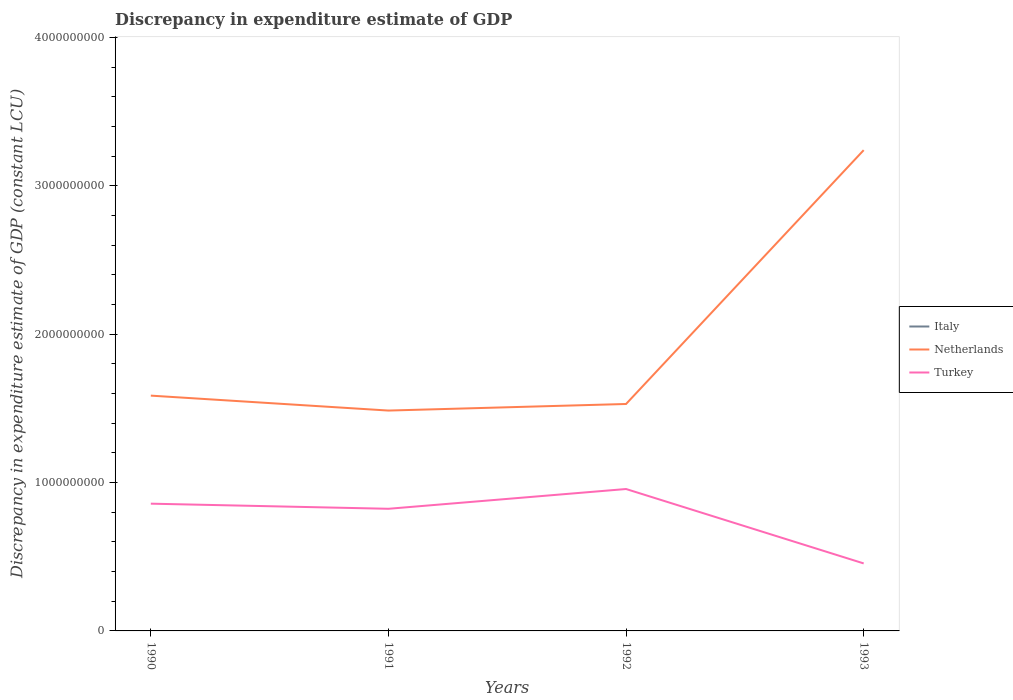How many different coloured lines are there?
Your response must be concise. 2. Across all years, what is the maximum discrepancy in expenditure estimate of GDP in Italy?
Offer a terse response. 0. What is the total discrepancy in expenditure estimate of GDP in Turkey in the graph?
Offer a terse response. 5.02e+08. What is the difference between the highest and the second highest discrepancy in expenditure estimate of GDP in Netherlands?
Provide a short and direct response. 1.76e+09. What is the difference between the highest and the lowest discrepancy in expenditure estimate of GDP in Italy?
Provide a short and direct response. 0. Is the discrepancy in expenditure estimate of GDP in Italy strictly greater than the discrepancy in expenditure estimate of GDP in Turkey over the years?
Offer a terse response. Yes. How many lines are there?
Provide a succinct answer. 2. How many years are there in the graph?
Your response must be concise. 4. What is the difference between two consecutive major ticks on the Y-axis?
Give a very brief answer. 1.00e+09. Does the graph contain any zero values?
Offer a terse response. Yes. Where does the legend appear in the graph?
Provide a short and direct response. Center right. How many legend labels are there?
Offer a very short reply. 3. What is the title of the graph?
Keep it short and to the point. Discrepancy in expenditure estimate of GDP. Does "Virgin Islands" appear as one of the legend labels in the graph?
Provide a succinct answer. No. What is the label or title of the Y-axis?
Keep it short and to the point. Discrepancy in expenditure estimate of GDP (constant LCU). What is the Discrepancy in expenditure estimate of GDP (constant LCU) in Netherlands in 1990?
Offer a terse response. 1.59e+09. What is the Discrepancy in expenditure estimate of GDP (constant LCU) of Turkey in 1990?
Give a very brief answer. 8.58e+08. What is the Discrepancy in expenditure estimate of GDP (constant LCU) of Italy in 1991?
Offer a terse response. 0. What is the Discrepancy in expenditure estimate of GDP (constant LCU) in Netherlands in 1991?
Keep it short and to the point. 1.49e+09. What is the Discrepancy in expenditure estimate of GDP (constant LCU) in Turkey in 1991?
Keep it short and to the point. 8.23e+08. What is the Discrepancy in expenditure estimate of GDP (constant LCU) of Netherlands in 1992?
Keep it short and to the point. 1.53e+09. What is the Discrepancy in expenditure estimate of GDP (constant LCU) in Turkey in 1992?
Ensure brevity in your answer.  9.57e+08. What is the Discrepancy in expenditure estimate of GDP (constant LCU) of Netherlands in 1993?
Give a very brief answer. 3.24e+09. What is the Discrepancy in expenditure estimate of GDP (constant LCU) of Turkey in 1993?
Your response must be concise. 4.55e+08. Across all years, what is the maximum Discrepancy in expenditure estimate of GDP (constant LCU) of Netherlands?
Offer a terse response. 3.24e+09. Across all years, what is the maximum Discrepancy in expenditure estimate of GDP (constant LCU) in Turkey?
Ensure brevity in your answer.  9.57e+08. Across all years, what is the minimum Discrepancy in expenditure estimate of GDP (constant LCU) of Netherlands?
Your answer should be compact. 1.49e+09. Across all years, what is the minimum Discrepancy in expenditure estimate of GDP (constant LCU) in Turkey?
Your response must be concise. 4.55e+08. What is the total Discrepancy in expenditure estimate of GDP (constant LCU) of Italy in the graph?
Your response must be concise. 0. What is the total Discrepancy in expenditure estimate of GDP (constant LCU) of Netherlands in the graph?
Keep it short and to the point. 7.84e+09. What is the total Discrepancy in expenditure estimate of GDP (constant LCU) of Turkey in the graph?
Keep it short and to the point. 3.09e+09. What is the difference between the Discrepancy in expenditure estimate of GDP (constant LCU) of Netherlands in 1990 and that in 1991?
Your answer should be very brief. 1.01e+08. What is the difference between the Discrepancy in expenditure estimate of GDP (constant LCU) in Turkey in 1990 and that in 1991?
Offer a very short reply. 3.45e+07. What is the difference between the Discrepancy in expenditure estimate of GDP (constant LCU) of Netherlands in 1990 and that in 1992?
Make the answer very short. 5.64e+07. What is the difference between the Discrepancy in expenditure estimate of GDP (constant LCU) in Turkey in 1990 and that in 1992?
Make the answer very short. -9.88e+07. What is the difference between the Discrepancy in expenditure estimate of GDP (constant LCU) in Netherlands in 1990 and that in 1993?
Provide a short and direct response. -1.66e+09. What is the difference between the Discrepancy in expenditure estimate of GDP (constant LCU) in Turkey in 1990 and that in 1993?
Your answer should be very brief. 4.03e+08. What is the difference between the Discrepancy in expenditure estimate of GDP (constant LCU) of Netherlands in 1991 and that in 1992?
Your response must be concise. -4.44e+07. What is the difference between the Discrepancy in expenditure estimate of GDP (constant LCU) in Turkey in 1991 and that in 1992?
Your answer should be very brief. -1.33e+08. What is the difference between the Discrepancy in expenditure estimate of GDP (constant LCU) in Netherlands in 1991 and that in 1993?
Provide a short and direct response. -1.76e+09. What is the difference between the Discrepancy in expenditure estimate of GDP (constant LCU) in Turkey in 1991 and that in 1993?
Offer a very short reply. 3.68e+08. What is the difference between the Discrepancy in expenditure estimate of GDP (constant LCU) in Netherlands in 1992 and that in 1993?
Offer a very short reply. -1.71e+09. What is the difference between the Discrepancy in expenditure estimate of GDP (constant LCU) of Turkey in 1992 and that in 1993?
Ensure brevity in your answer.  5.02e+08. What is the difference between the Discrepancy in expenditure estimate of GDP (constant LCU) in Netherlands in 1990 and the Discrepancy in expenditure estimate of GDP (constant LCU) in Turkey in 1991?
Your response must be concise. 7.63e+08. What is the difference between the Discrepancy in expenditure estimate of GDP (constant LCU) of Netherlands in 1990 and the Discrepancy in expenditure estimate of GDP (constant LCU) of Turkey in 1992?
Your response must be concise. 6.30e+08. What is the difference between the Discrepancy in expenditure estimate of GDP (constant LCU) in Netherlands in 1990 and the Discrepancy in expenditure estimate of GDP (constant LCU) in Turkey in 1993?
Provide a succinct answer. 1.13e+09. What is the difference between the Discrepancy in expenditure estimate of GDP (constant LCU) in Netherlands in 1991 and the Discrepancy in expenditure estimate of GDP (constant LCU) in Turkey in 1992?
Provide a succinct answer. 5.29e+08. What is the difference between the Discrepancy in expenditure estimate of GDP (constant LCU) in Netherlands in 1991 and the Discrepancy in expenditure estimate of GDP (constant LCU) in Turkey in 1993?
Make the answer very short. 1.03e+09. What is the difference between the Discrepancy in expenditure estimate of GDP (constant LCU) of Netherlands in 1992 and the Discrepancy in expenditure estimate of GDP (constant LCU) of Turkey in 1993?
Provide a short and direct response. 1.08e+09. What is the average Discrepancy in expenditure estimate of GDP (constant LCU) of Italy per year?
Offer a terse response. 0. What is the average Discrepancy in expenditure estimate of GDP (constant LCU) of Netherlands per year?
Give a very brief answer. 1.96e+09. What is the average Discrepancy in expenditure estimate of GDP (constant LCU) of Turkey per year?
Your answer should be compact. 7.73e+08. In the year 1990, what is the difference between the Discrepancy in expenditure estimate of GDP (constant LCU) in Netherlands and Discrepancy in expenditure estimate of GDP (constant LCU) in Turkey?
Provide a short and direct response. 7.29e+08. In the year 1991, what is the difference between the Discrepancy in expenditure estimate of GDP (constant LCU) in Netherlands and Discrepancy in expenditure estimate of GDP (constant LCU) in Turkey?
Provide a short and direct response. 6.62e+08. In the year 1992, what is the difference between the Discrepancy in expenditure estimate of GDP (constant LCU) in Netherlands and Discrepancy in expenditure estimate of GDP (constant LCU) in Turkey?
Your answer should be very brief. 5.73e+08. In the year 1993, what is the difference between the Discrepancy in expenditure estimate of GDP (constant LCU) in Netherlands and Discrepancy in expenditure estimate of GDP (constant LCU) in Turkey?
Keep it short and to the point. 2.79e+09. What is the ratio of the Discrepancy in expenditure estimate of GDP (constant LCU) in Netherlands in 1990 to that in 1991?
Your response must be concise. 1.07. What is the ratio of the Discrepancy in expenditure estimate of GDP (constant LCU) in Turkey in 1990 to that in 1991?
Your response must be concise. 1.04. What is the ratio of the Discrepancy in expenditure estimate of GDP (constant LCU) in Netherlands in 1990 to that in 1992?
Offer a terse response. 1.04. What is the ratio of the Discrepancy in expenditure estimate of GDP (constant LCU) in Turkey in 1990 to that in 1992?
Ensure brevity in your answer.  0.9. What is the ratio of the Discrepancy in expenditure estimate of GDP (constant LCU) of Netherlands in 1990 to that in 1993?
Your response must be concise. 0.49. What is the ratio of the Discrepancy in expenditure estimate of GDP (constant LCU) in Turkey in 1990 to that in 1993?
Offer a very short reply. 1.89. What is the ratio of the Discrepancy in expenditure estimate of GDP (constant LCU) of Netherlands in 1991 to that in 1992?
Make the answer very short. 0.97. What is the ratio of the Discrepancy in expenditure estimate of GDP (constant LCU) of Turkey in 1991 to that in 1992?
Your answer should be very brief. 0.86. What is the ratio of the Discrepancy in expenditure estimate of GDP (constant LCU) of Netherlands in 1991 to that in 1993?
Your answer should be very brief. 0.46. What is the ratio of the Discrepancy in expenditure estimate of GDP (constant LCU) of Turkey in 1991 to that in 1993?
Provide a short and direct response. 1.81. What is the ratio of the Discrepancy in expenditure estimate of GDP (constant LCU) in Netherlands in 1992 to that in 1993?
Make the answer very short. 0.47. What is the ratio of the Discrepancy in expenditure estimate of GDP (constant LCU) of Turkey in 1992 to that in 1993?
Provide a succinct answer. 2.1. What is the difference between the highest and the second highest Discrepancy in expenditure estimate of GDP (constant LCU) of Netherlands?
Provide a succinct answer. 1.66e+09. What is the difference between the highest and the second highest Discrepancy in expenditure estimate of GDP (constant LCU) in Turkey?
Your answer should be compact. 9.88e+07. What is the difference between the highest and the lowest Discrepancy in expenditure estimate of GDP (constant LCU) in Netherlands?
Provide a short and direct response. 1.76e+09. What is the difference between the highest and the lowest Discrepancy in expenditure estimate of GDP (constant LCU) of Turkey?
Your answer should be compact. 5.02e+08. 